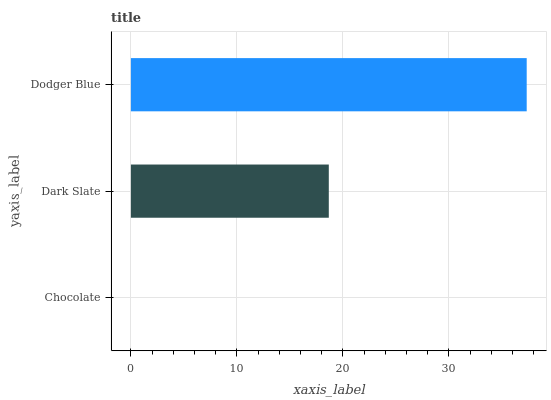Is Chocolate the minimum?
Answer yes or no. Yes. Is Dodger Blue the maximum?
Answer yes or no. Yes. Is Dark Slate the minimum?
Answer yes or no. No. Is Dark Slate the maximum?
Answer yes or no. No. Is Dark Slate greater than Chocolate?
Answer yes or no. Yes. Is Chocolate less than Dark Slate?
Answer yes or no. Yes. Is Chocolate greater than Dark Slate?
Answer yes or no. No. Is Dark Slate less than Chocolate?
Answer yes or no. No. Is Dark Slate the high median?
Answer yes or no. Yes. Is Dark Slate the low median?
Answer yes or no. Yes. Is Dodger Blue the high median?
Answer yes or no. No. Is Dodger Blue the low median?
Answer yes or no. No. 